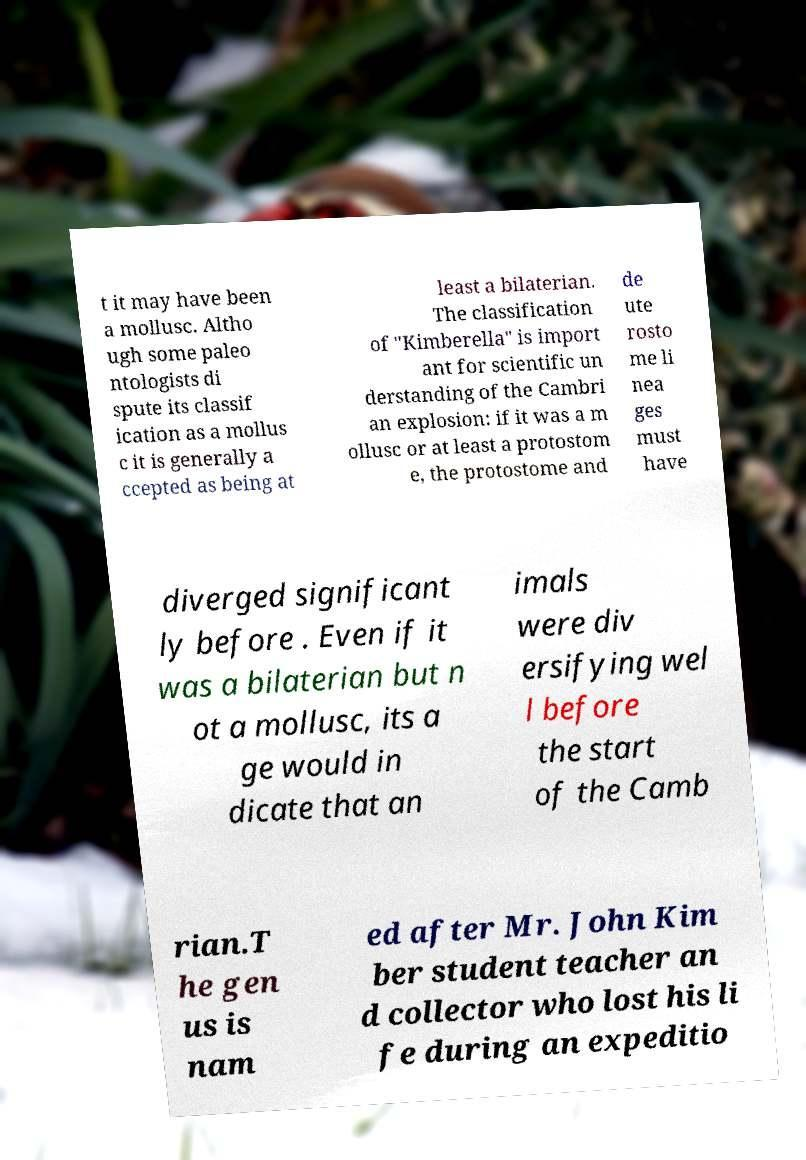What messages or text are displayed in this image? I need them in a readable, typed format. t it may have been a mollusc. Altho ugh some paleo ntologists di spute its classif ication as a mollus c it is generally a ccepted as being at least a bilaterian. The classification of "Kimberella" is import ant for scientific un derstanding of the Cambri an explosion: if it was a m ollusc or at least a protostom e, the protostome and de ute rosto me li nea ges must have diverged significant ly before . Even if it was a bilaterian but n ot a mollusc, its a ge would in dicate that an imals were div ersifying wel l before the start of the Camb rian.T he gen us is nam ed after Mr. John Kim ber student teacher an d collector who lost his li fe during an expeditio 